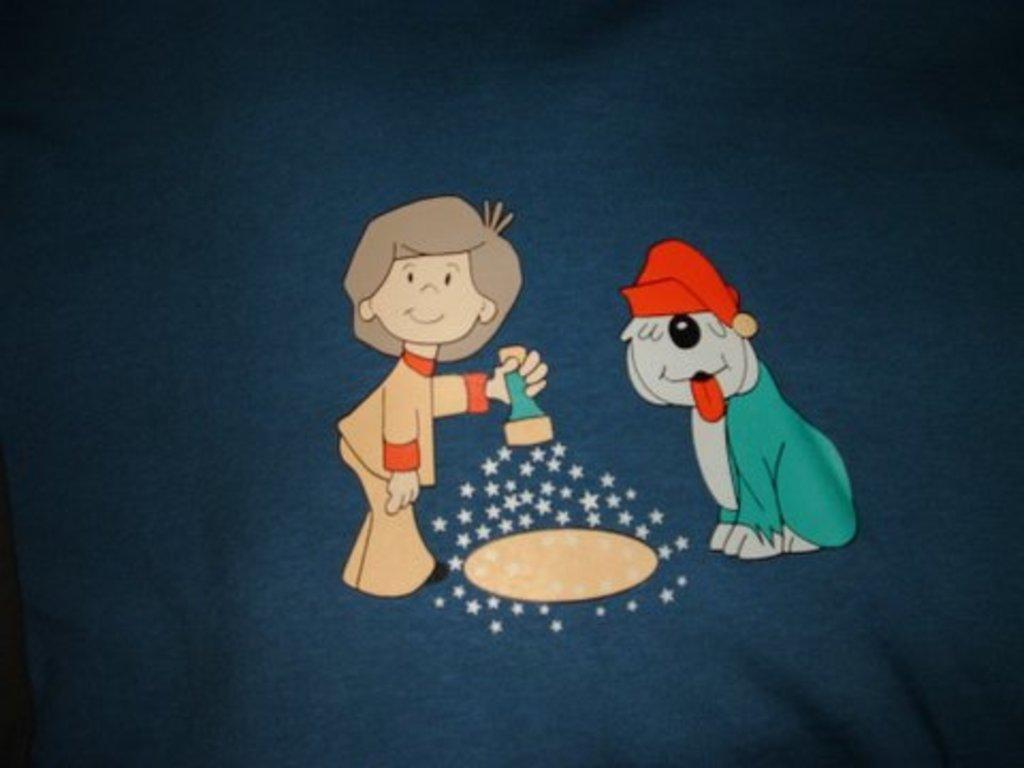Can you describe this image briefly? This is an animated image of a dog and a girl holding a torch. 